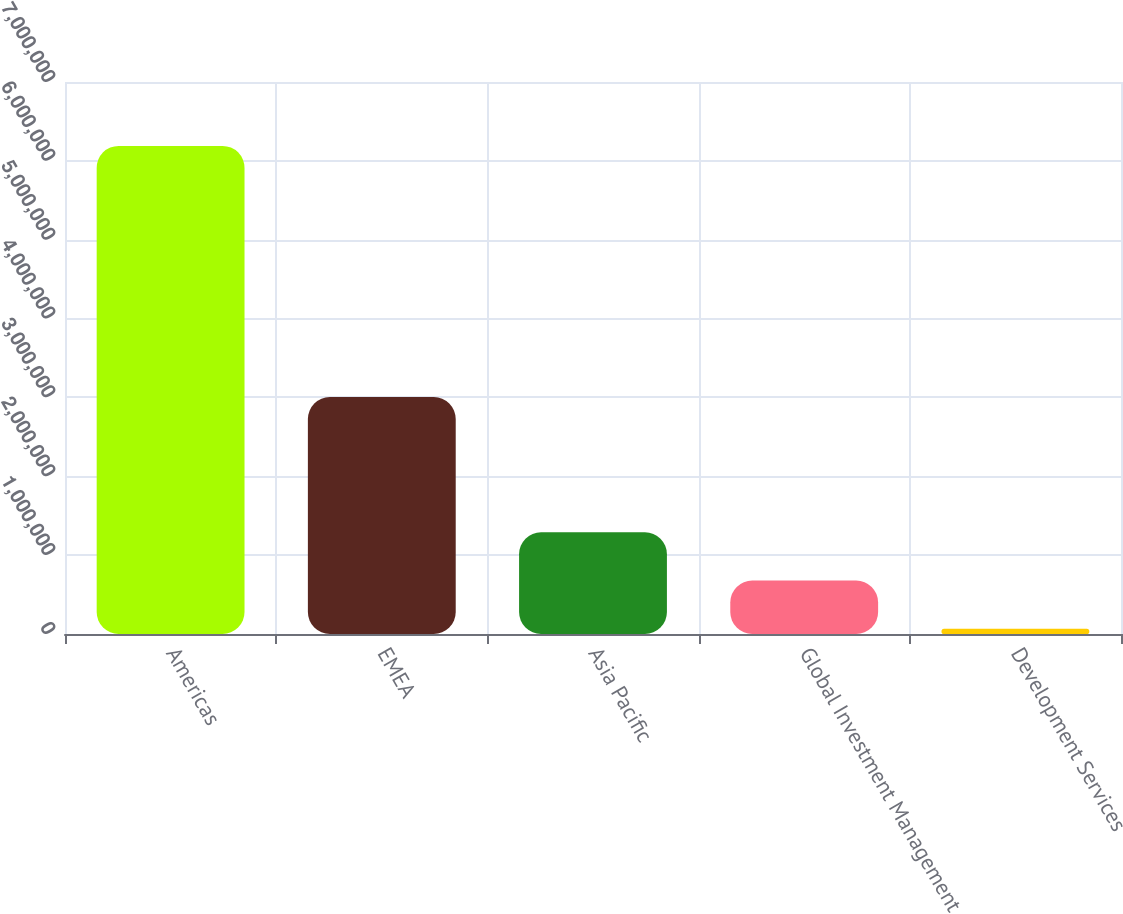<chart> <loc_0><loc_0><loc_500><loc_500><bar_chart><fcel>Americas<fcel>EMEA<fcel>Asia Pacific<fcel>Global Investment Management<fcel>Development Services<nl><fcel>6.18991e+06<fcel>3.00448e+06<fcel>1.2905e+06<fcel>678070<fcel>65643<nl></chart> 